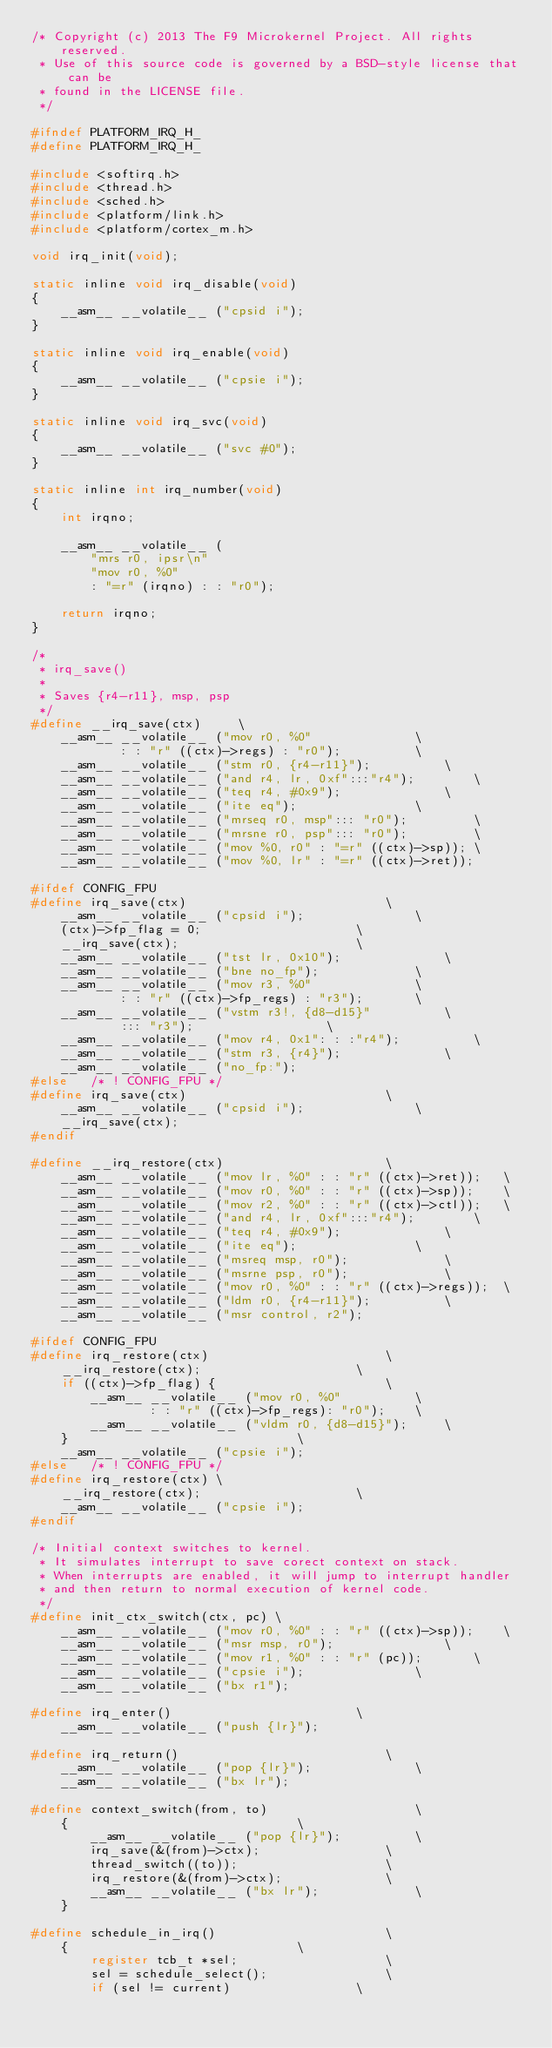<code> <loc_0><loc_0><loc_500><loc_500><_C_>/* Copyright (c) 2013 The F9 Microkernel Project. All rights reserved.
 * Use of this source code is governed by a BSD-style license that can be
 * found in the LICENSE file.
 */

#ifndef PLATFORM_IRQ_H_
#define PLATFORM_IRQ_H_

#include <softirq.h>
#include <thread.h>
#include <sched.h>
#include <platform/link.h>
#include <platform/cortex_m.h>

void irq_init(void);

static inline void irq_disable(void)
{
	__asm__ __volatile__ ("cpsid i");
}

static inline void irq_enable(void)
{
	__asm__ __volatile__ ("cpsie i");
}

static inline void irq_svc(void)
{
	__asm__ __volatile__ ("svc #0");
}

static inline int irq_number(void)
{
	int irqno;

	__asm__ __volatile__ (
		"mrs r0, ipsr\n"
		"mov r0, %0"
		: "=r" (irqno) : : "r0");

	return irqno;
}

/*
 * irq_save()
 *
 * Saves {r4-r11}, msp, psp
 */
#define __irq_save(ctx)		\
	__asm__ __volatile__ ("mov r0, %0"				\
			: : "r" ((ctx)->regs) : "r0");			\
	__asm__ __volatile__ ("stm r0, {r4-r11}");			\
	__asm__ __volatile__ ("and r4, lr, 0xf":::"r4");		\
	__asm__ __volatile__ ("teq r4, #0x9");				\
	__asm__ __volatile__ ("ite eq");				\
	__asm__ __volatile__ ("mrseq r0, msp"::: "r0");			\
	__asm__ __volatile__ ("mrsne r0, psp"::: "r0");			\
	__asm__ __volatile__ ("mov %0, r0" : "=r" ((ctx)->sp));	\
	__asm__ __volatile__ ("mov %0, lr" : "=r" ((ctx)->ret));

#ifdef CONFIG_FPU
#define irq_save(ctx)							\
	__asm__ __volatile__ ("cpsid i");				\
	(ctx)->fp_flag = 0;						\
	__irq_save(ctx);						\
	__asm__ __volatile__ ("tst lr, 0x10");				\
	__asm__ __volatile__ ("bne no_fp");				\
	__asm__ __volatile__ ("mov r3, %0"				\
			: : "r" ((ctx)->fp_regs) : "r3");		\
	__asm__ __volatile__ ("vstm r3!, {d8-d15}"			\
			::: "r3");					\
	__asm__ __volatile__ ("mov r4, 0x1": : :"r4");			\
	__asm__ __volatile__ ("stm r3, {r4}");				\
	__asm__ __volatile__ ("no_fp:");
#else	/* ! CONFIG_FPU */
#define irq_save(ctx)							\
	__asm__ __volatile__ ("cpsid i");				\
	__irq_save(ctx);
#endif

#define __irq_restore(ctx)						\
	__asm__ __volatile__ ("mov lr, %0" : : "r" ((ctx)->ret));	\
	__asm__ __volatile__ ("mov r0, %0" : : "r" ((ctx)->sp));	\
	__asm__ __volatile__ ("mov r2, %0" : : "r" ((ctx)->ctl));	\
	__asm__ __volatile__ ("and r4, lr, 0xf":::"r4");		\
	__asm__ __volatile__ ("teq r4, #0x9");				\
	__asm__ __volatile__ ("ite eq");				\
	__asm__ __volatile__ ("msreq msp, r0");				\
	__asm__ __volatile__ ("msrne psp, r0");				\
	__asm__ __volatile__ ("mov r0, %0" : : "r" ((ctx)->regs));	\
	__asm__ __volatile__ ("ldm r0, {r4-r11}");			\
	__asm__ __volatile__ ("msr control, r2");

#ifdef CONFIG_FPU
#define irq_restore(ctx)						\
	__irq_restore(ctx);						\
	if ((ctx)->fp_flag) {						\
		__asm__ __volatile__ ("mov r0, %0" 			\
				: : "r" ((ctx)->fp_regs): "r0");	\
		__asm__ __volatile__ ("vldm r0, {d8-d15}");		\
	}								\
	__asm__ __volatile__ ("cpsie i");
#else	/* ! CONFIG_FPU */
#define irq_restore(ctx) \
	__irq_restore(ctx);						\
	__asm__ __volatile__ ("cpsie i");
#endif

/* Initial context switches to kernel.
 * It simulates interrupt to save corect context on stack.
 * When interrupts are enabled, it will jump to interrupt handler
 * and then return to normal execution of kernel code.
 */
#define init_ctx_switch(ctx, pc) \
	__asm__ __volatile__ ("mov r0, %0" : : "r" ((ctx)->sp));	\
	__asm__ __volatile__ ("msr msp, r0");				\
	__asm__ __volatile__ ("mov r1, %0" : : "r" (pc));		\
	__asm__ __volatile__ ("cpsie i");				\
	__asm__ __volatile__ ("bx r1");

#define irq_enter()							\
	__asm__ __volatile__ ("push {lr}");

#define irq_return()							\
	__asm__ __volatile__ ("pop {lr}");				\
	__asm__ __volatile__ ("bx lr");

#define context_switch(from, to)					\
	{								\
		__asm__ __volatile__ ("pop {lr}");			\
		irq_save(&(from)->ctx);					\
		thread_switch((to));					\
		irq_restore(&(from)->ctx);				\
		__asm__ __volatile__ ("bx lr");				\
	}

#define schedule_in_irq()						\
	{								\
		register tcb_t *sel;					\
		sel = schedule_select();				\
		if (sel != current)					\</code> 